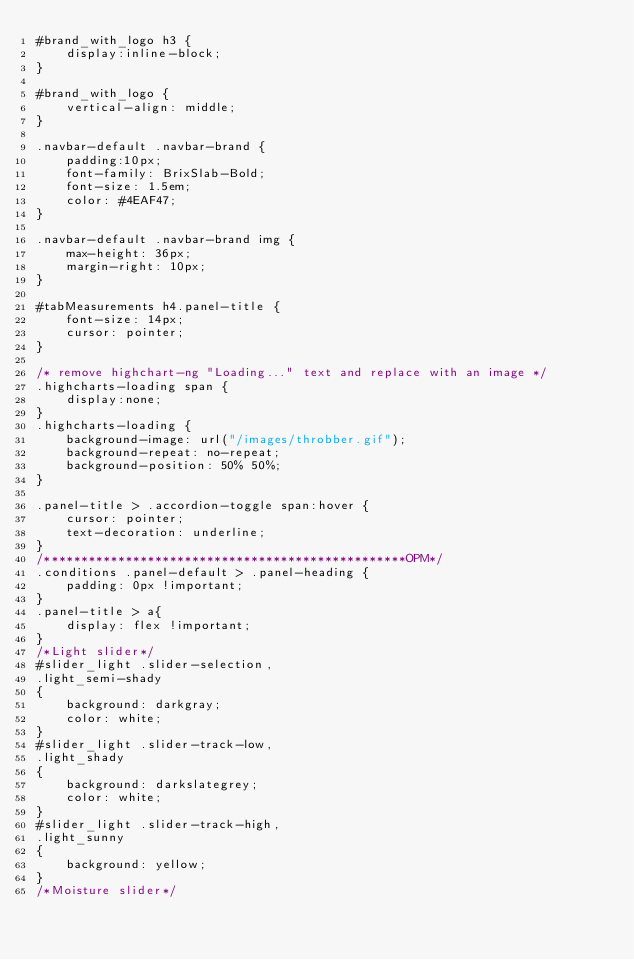<code> <loc_0><loc_0><loc_500><loc_500><_CSS_>#brand_with_logo h3 {
    display:inline-block;
}

#brand_with_logo {
    vertical-align: middle;
}

.navbar-default .navbar-brand {
    padding:10px;
    font-family: BrixSlab-Bold;
    font-size: 1.5em;
    color: #4EAF47;
}

.navbar-default .navbar-brand img {
    max-height: 36px;
    margin-right: 10px;
}

#tabMeasurements h4.panel-title {
    font-size: 14px;
    cursor: pointer;
}

/* remove highchart-ng "Loading..." text and replace with an image */
.highcharts-loading span {
    display:none;
}
.highcharts-loading {
    background-image: url("/images/throbber.gif");
    background-repeat: no-repeat;
    background-position: 50% 50%;
}

.panel-title > .accordion-toggle span:hover {
    cursor: pointer;
    text-decoration: underline;
}
/*************************************************OPM*/
.conditions .panel-default > .panel-heading {
    padding: 0px !important;
}
.panel-title > a{
    display: flex !important;
}
/*Light slider*/
#slider_light .slider-selection,
.light_semi-shady
{
    background: darkgray;
    color: white;
}
#slider_light .slider-track-low,
.light_shady
{
    background: darkslategrey;
    color: white;
}
#slider_light .slider-track-high,
.light_sunny
{
    background: yellow;
}
/*Moisture slider*/</code> 